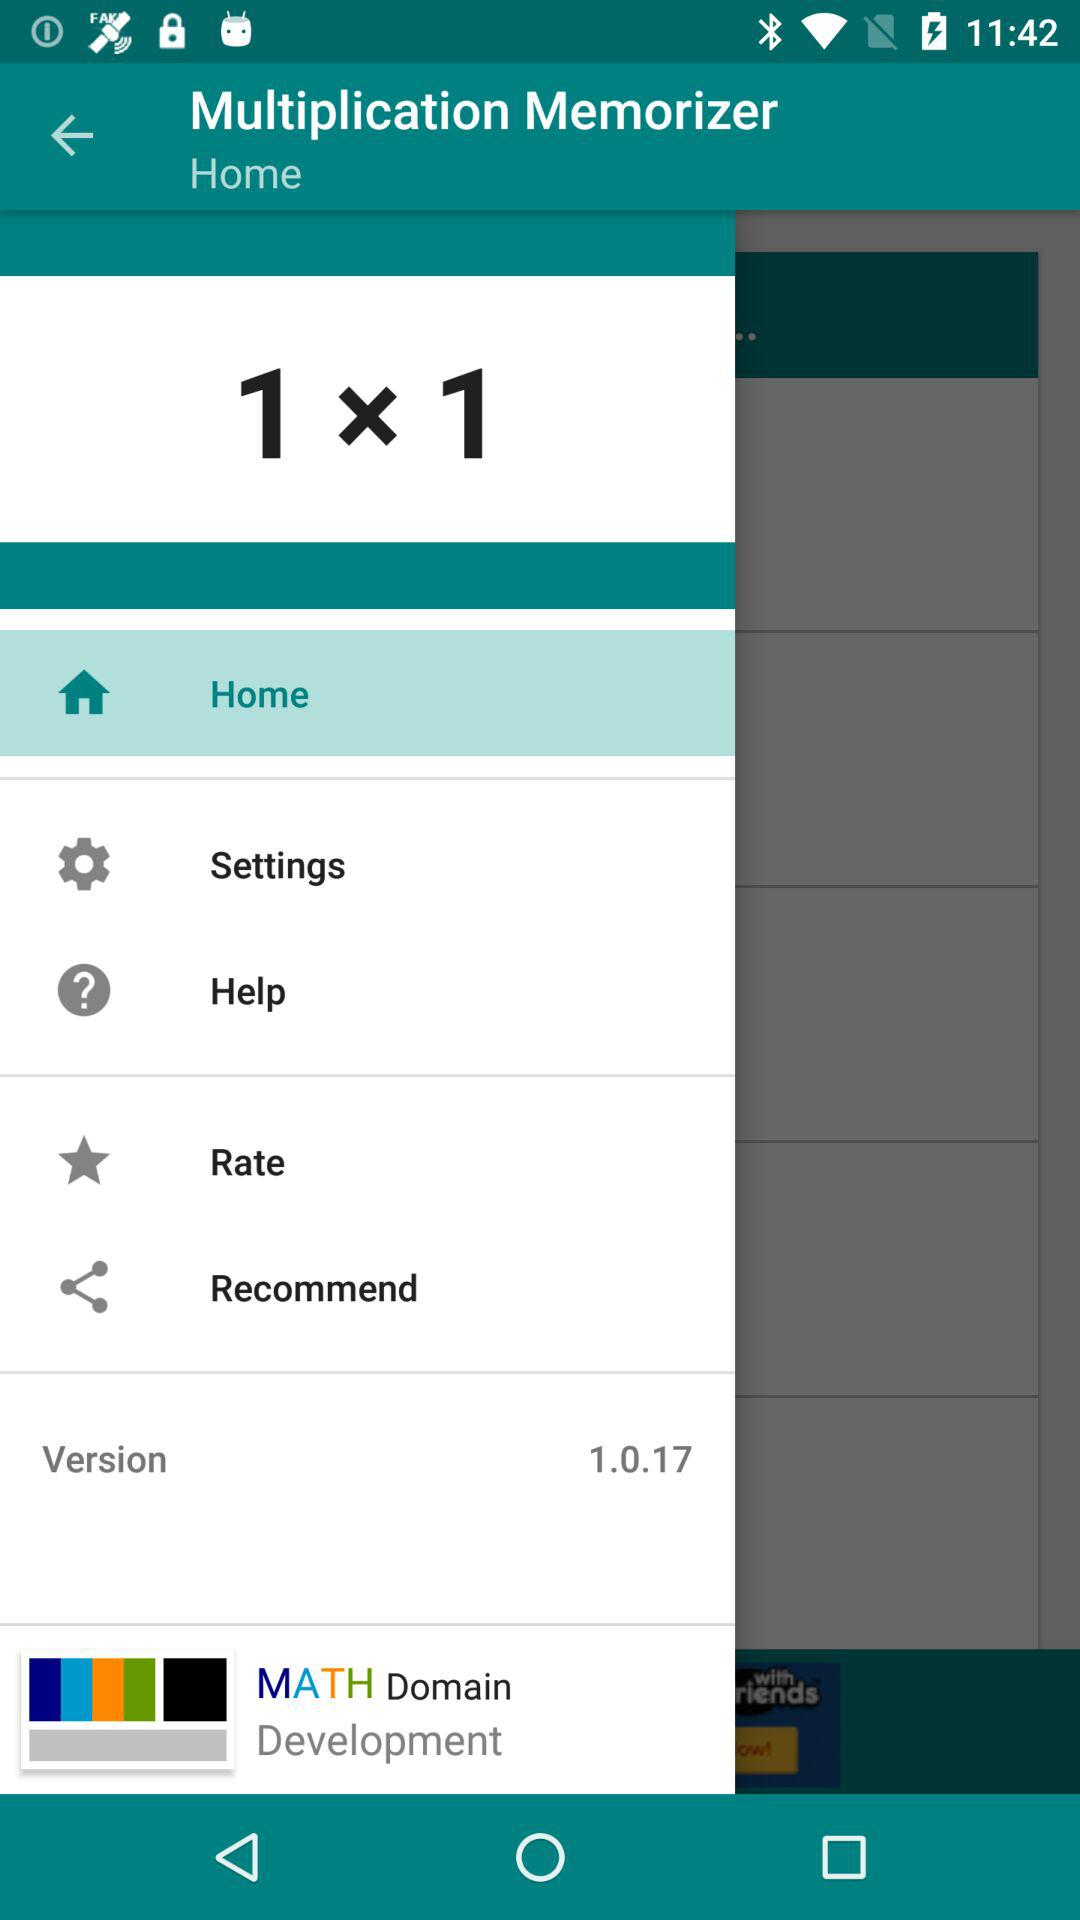What is the sum of the numbers in the equation?
Answer the question using a single word or phrase. 2 